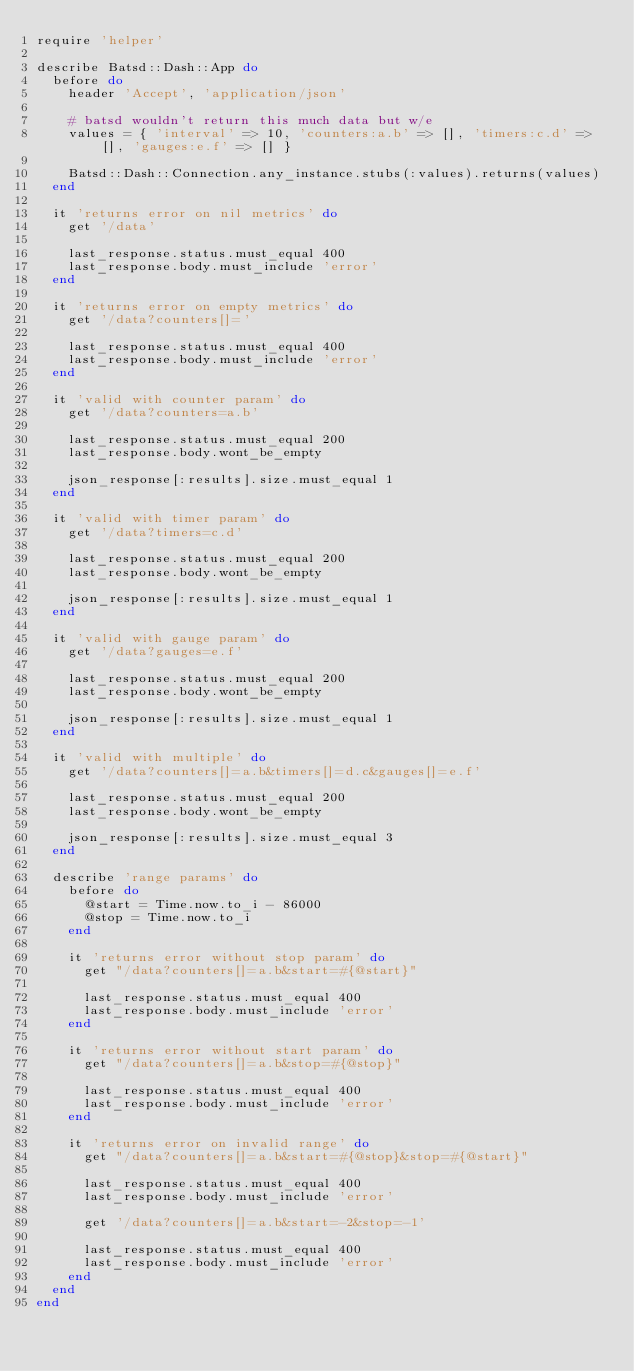Convert code to text. <code><loc_0><loc_0><loc_500><loc_500><_Ruby_>require 'helper'

describe Batsd::Dash::App do
  before do
    header 'Accept', 'application/json'

    # batsd wouldn't return this much data but w/e
    values = { 'interval' => 10, 'counters:a.b' => [], 'timers:c.d' => [], 'gauges:e.f' => [] }

    Batsd::Dash::Connection.any_instance.stubs(:values).returns(values)
  end

  it 'returns error on nil metrics' do
    get '/data'

    last_response.status.must_equal 400
    last_response.body.must_include 'error'
  end

  it 'returns error on empty metrics' do
    get '/data?counters[]='

    last_response.status.must_equal 400
    last_response.body.must_include 'error'
  end

  it 'valid with counter param' do
    get '/data?counters=a.b'

    last_response.status.must_equal 200
    last_response.body.wont_be_empty

    json_response[:results].size.must_equal 1
  end

  it 'valid with timer param' do
    get '/data?timers=c.d'

    last_response.status.must_equal 200
    last_response.body.wont_be_empty

    json_response[:results].size.must_equal 1
  end

  it 'valid with gauge param' do
    get '/data?gauges=e.f'

    last_response.status.must_equal 200
    last_response.body.wont_be_empty

    json_response[:results].size.must_equal 1
  end

  it 'valid with multiple' do
    get '/data?counters[]=a.b&timers[]=d.c&gauges[]=e.f'

    last_response.status.must_equal 200
    last_response.body.wont_be_empty

    json_response[:results].size.must_equal 3
  end

  describe 'range params' do
    before do
      @start = Time.now.to_i - 86000
      @stop = Time.now.to_i
    end

    it 'returns error without stop param' do
      get "/data?counters[]=a.b&start=#{@start}"

      last_response.status.must_equal 400
      last_response.body.must_include 'error'
    end

    it 'returns error without start param' do
      get "/data?counters[]=a.b&stop=#{@stop}"

      last_response.status.must_equal 400
      last_response.body.must_include 'error'
    end

    it 'returns error on invalid range' do
      get "/data?counters[]=a.b&start=#{@stop}&stop=#{@start}"

      last_response.status.must_equal 400
      last_response.body.must_include 'error'

      get '/data?counters[]=a.b&start=-2&stop=-1'

      last_response.status.must_equal 400
      last_response.body.must_include 'error'
    end
  end
end
</code> 